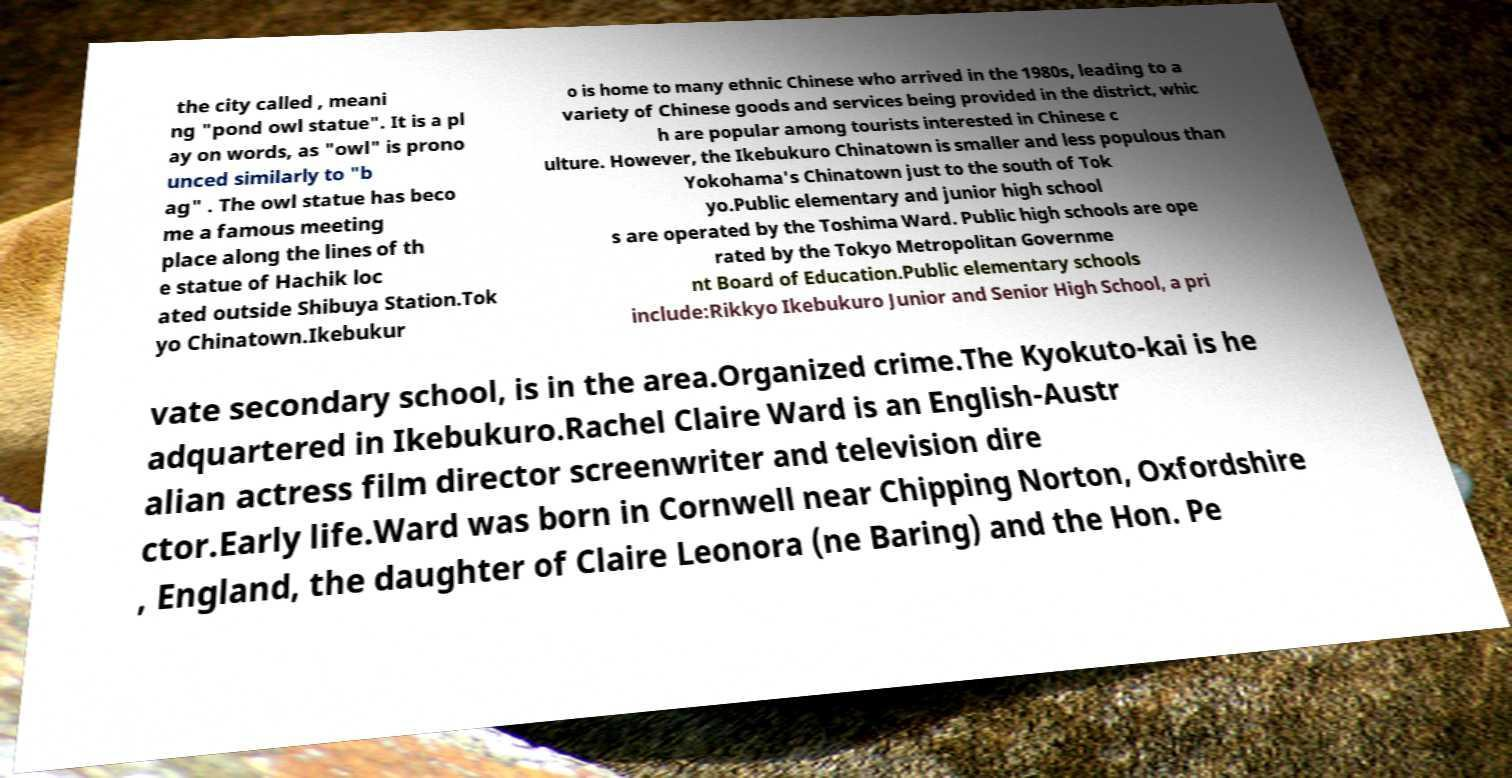What messages or text are displayed in this image? I need them in a readable, typed format. the city called , meani ng "pond owl statue". It is a pl ay on words, as "owl" is prono unced similarly to "b ag" . The owl statue has beco me a famous meeting place along the lines of th e statue of Hachik loc ated outside Shibuya Station.Tok yo Chinatown.Ikebukur o is home to many ethnic Chinese who arrived in the 1980s, leading to a variety of Chinese goods and services being provided in the district, whic h are popular among tourists interested in Chinese c ulture. However, the Ikebukuro Chinatown is smaller and less populous than Yokohama's Chinatown just to the south of Tok yo.Public elementary and junior high school s are operated by the Toshima Ward. Public high schools are ope rated by the Tokyo Metropolitan Governme nt Board of Education.Public elementary schools include:Rikkyo Ikebukuro Junior and Senior High School, a pri vate secondary school, is in the area.Organized crime.The Kyokuto-kai is he adquartered in Ikebukuro.Rachel Claire Ward is an English-Austr alian actress film director screenwriter and television dire ctor.Early life.Ward was born in Cornwell near Chipping Norton, Oxfordshire , England, the daughter of Claire Leonora (ne Baring) and the Hon. Pe 